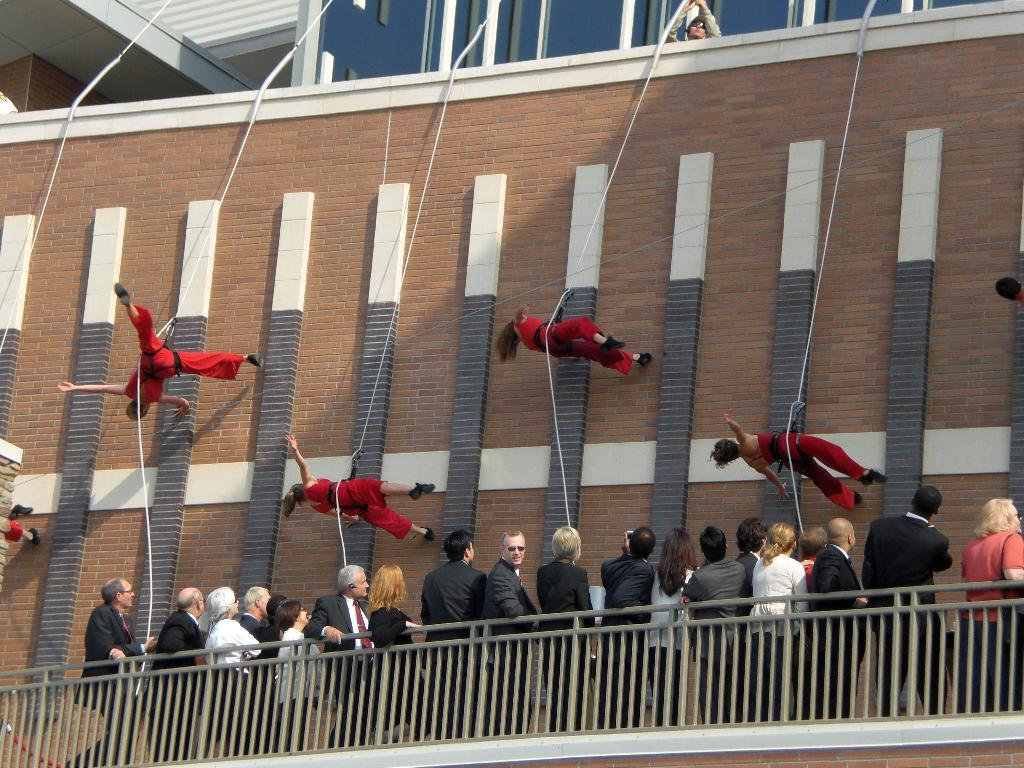What are the girls in the image doing? The girls in the image are climbing a wall. How are the girls assisted in their climb? The girls are holding ropes while climbing. What color dresses are the girls wearing? The girls are wearing red color dresses. Are there any spectators in the image? Yes, there are people standing and observing the game in the image. What type of love can be seen in the image? There is no love present in the image; it features girls climbing a wall while holding ropes. What answer is provided by the quartz in the image? There is no quartz present in the image, so no answer can be provided. 